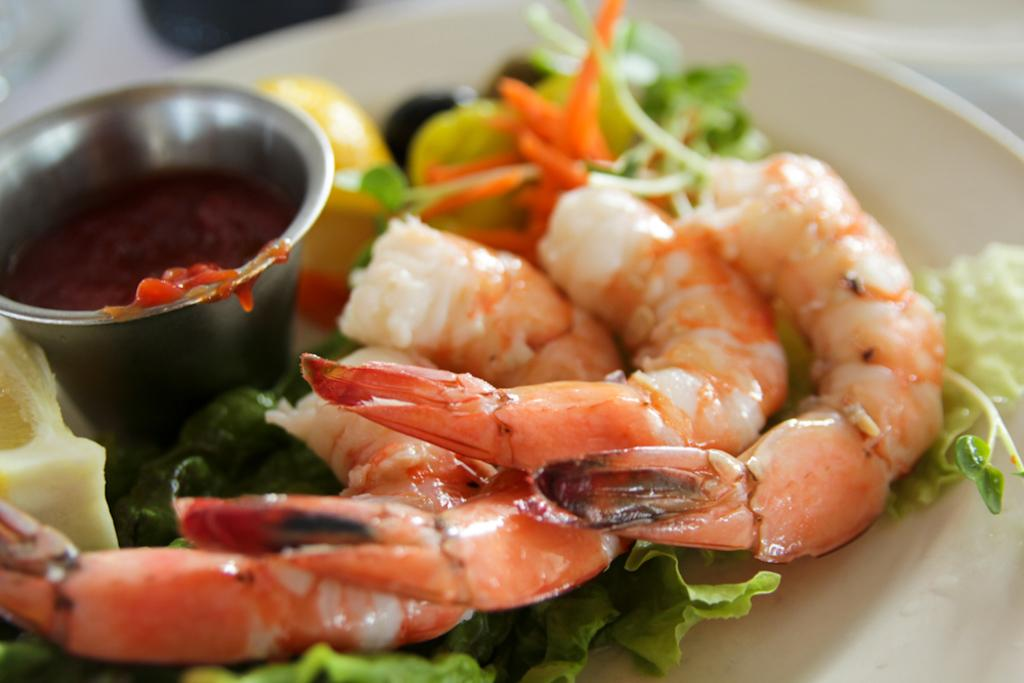What type of food is on the plate in the image? There is a plate containing shrimps in the image. What other type of food is on a separate plate in the image? There is a plate containing leafy vegetables in the image. What is the container for the sauce in the image? There is a bowl in the image. What is the purpose of the sauce in the image? The sauce is used to enhance the flavor of the food. Where are the plate, bowl, and sauce located in the image? The plate, bowl, and sauce are placed on a table. What type of egg is being combed in the image? There is no egg or comb present in the image. 